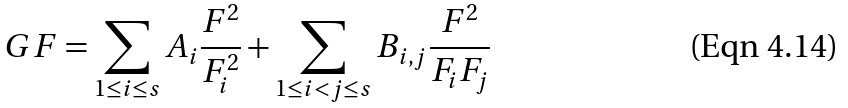<formula> <loc_0><loc_0><loc_500><loc_500>G F = \sum _ { 1 \leq i \leq s } A _ { i } \frac { F ^ { 2 } } { F _ { i } ^ { 2 } } + \sum _ { 1 \leq i < j \leq s } B _ { i , j } \frac { F ^ { 2 } } { F _ { i } F _ { j } }</formula> 